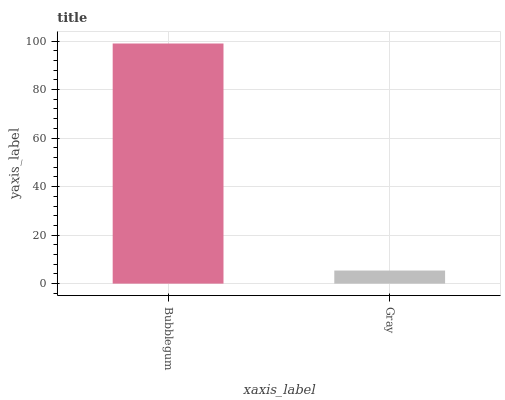Is Gray the minimum?
Answer yes or no. Yes. Is Bubblegum the maximum?
Answer yes or no. Yes. Is Gray the maximum?
Answer yes or no. No. Is Bubblegum greater than Gray?
Answer yes or no. Yes. Is Gray less than Bubblegum?
Answer yes or no. Yes. Is Gray greater than Bubblegum?
Answer yes or no. No. Is Bubblegum less than Gray?
Answer yes or no. No. Is Bubblegum the high median?
Answer yes or no. Yes. Is Gray the low median?
Answer yes or no. Yes. Is Gray the high median?
Answer yes or no. No. Is Bubblegum the low median?
Answer yes or no. No. 